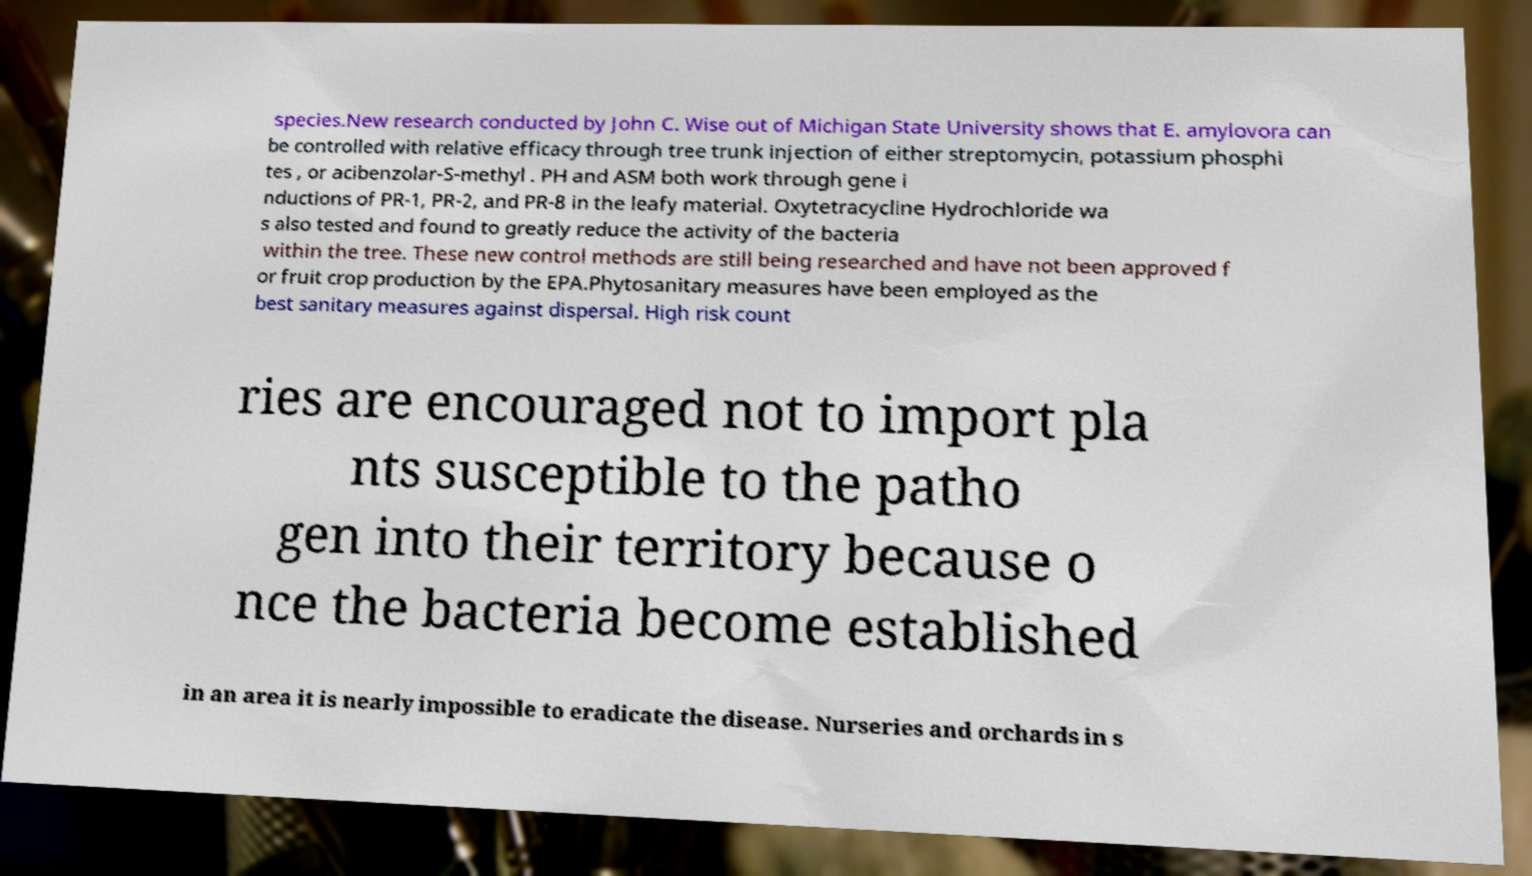Please read and relay the text visible in this image. What does it say? species.New research conducted by John C. Wise out of Michigan State University shows that E. amylovora can be controlled with relative efficacy through tree trunk injection of either streptomycin, potassium phosphi tes , or acibenzolar-S-methyl . PH and ASM both work through gene i nductions of PR-1, PR-2, and PR-8 in the leafy material. Oxytetracycline Hydrochloride wa s also tested and found to greatly reduce the activity of the bacteria within the tree. These new control methods are still being researched and have not been approved f or fruit crop production by the EPA.Phytosanitary measures have been employed as the best sanitary measures against dispersal. High risk count ries are encouraged not to import pla nts susceptible to the patho gen into their territory because o nce the bacteria become established in an area it is nearly impossible to eradicate the disease. Nurseries and orchards in s 